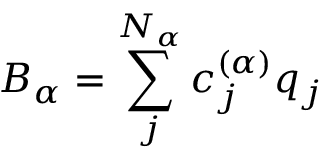Convert formula to latex. <formula><loc_0><loc_0><loc_500><loc_500>{ { B } _ { \alpha } } = \sum _ { j } ^ { { { N } _ { \alpha } } } { c _ { j } ^ { ( \alpha ) } } { { q } _ { j } }</formula> 